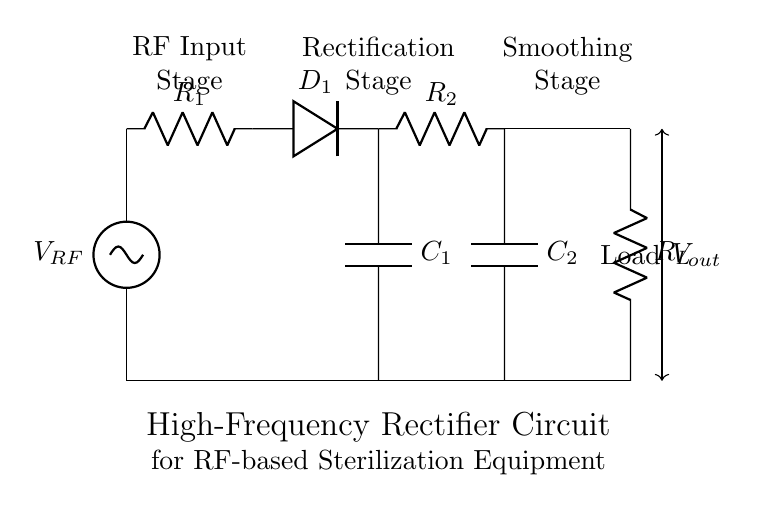What is the purpose of D1 in this circuit? D1 is a diode that rectifies the RF input voltage, allowing current to flow only in one direction, which is crucial for converting AC signals to DC.
Answer: Diode What is the role of C1 in the rectification stage? C1 functions as a filter capacitor that smooths the rectified output by reducing voltage ripple, hence providing a more stable DC voltage.
Answer: Filter capacitor How many resistors are present in the circuit? There are two resistors, R1 and R2, which help regulate current and provide stabilization in different stages of the circuit.
Answer: Two What is the output voltage labeled as in the circuit? The output voltage is labeled as V out, representing the voltage available to the load after rectification and smoothing.
Answer: V out What type of filter is implemented by using C2? C2 acts as a smoothing capacitor, which completes the low-pass filter design to reduce fluctuations in the output voltage.
Answer: Smoothing What is the connection between C1 and R2 in the circuit? C1 connects directly to R2, allowing smoothed DC output from the rectification stage to pass through to the load via R2.
Answer: Direct connection What main function does the load resistor R L serve? R L represents the actual load that consumes the rectified and smoothed DC power for RF-based sterilization processes.
Answer: Load 